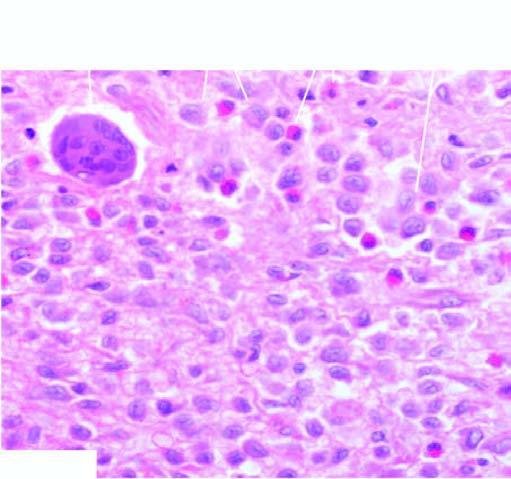does the pink acellular amyloid material show presence of infiltrate by collections of histiocytes having vesicular nuclei admixed with eosinophils?
Answer the question using a single word or phrase. No 